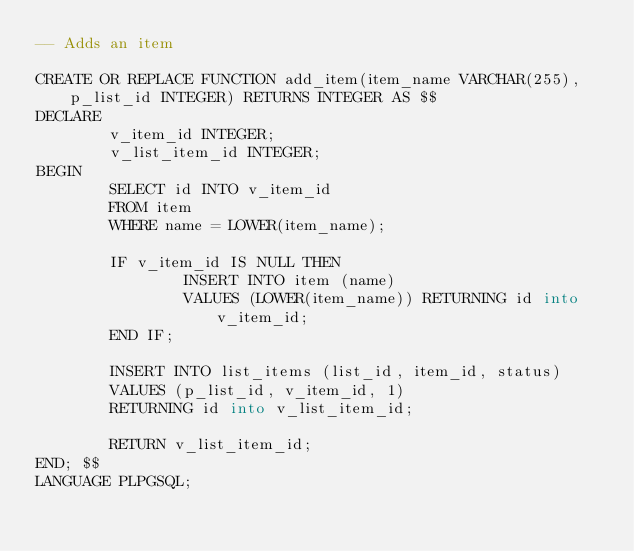Convert code to text. <code><loc_0><loc_0><loc_500><loc_500><_SQL_>-- Adds an item

CREATE OR REPLACE FUNCTION add_item(item_name VARCHAR(255), p_list_id INTEGER) RETURNS INTEGER AS $$
DECLARE
        v_item_id INTEGER;
        v_list_item_id INTEGER;
BEGIN
        SELECT id INTO v_item_id
        FROM item
        WHERE name = LOWER(item_name);

        IF v_item_id IS NULL THEN
                INSERT INTO item (name)
                VALUES (LOWER(item_name)) RETURNING id into v_item_id;
        END IF;

        INSERT INTO list_items (list_id, item_id, status)
        VALUES (p_list_id, v_item_id, 1)
        RETURNING id into v_list_item_id;

        RETURN v_list_item_id;
END; $$
LANGUAGE PLPGSQL;
</code> 